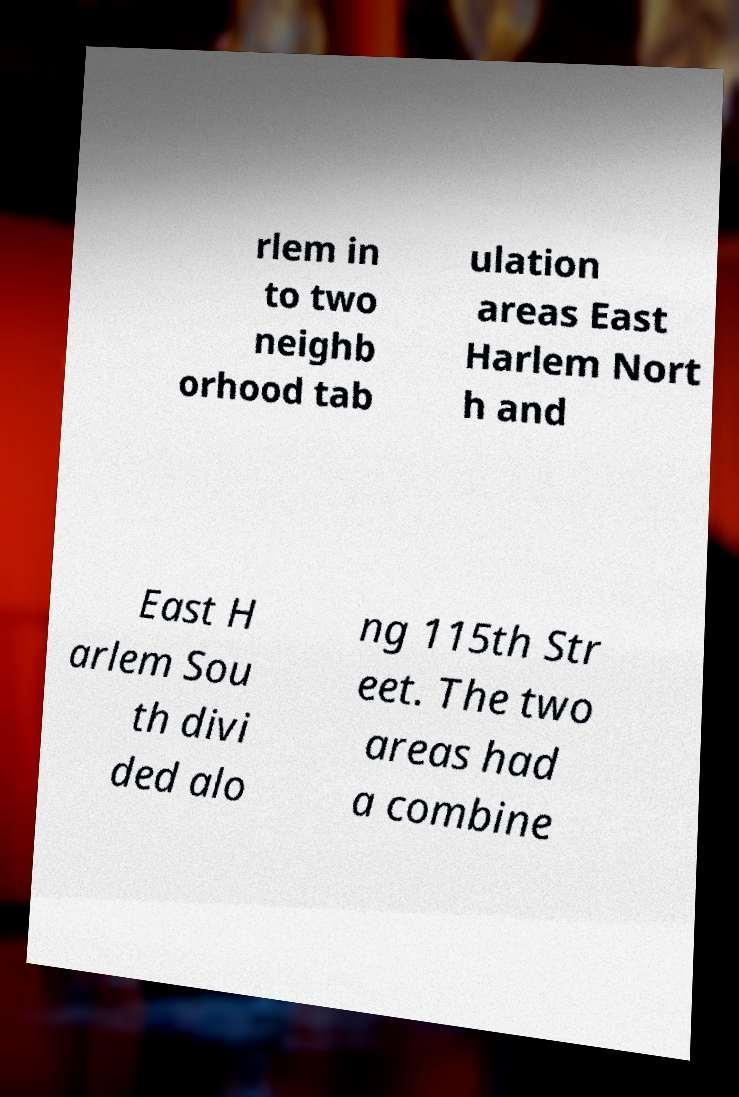Can you accurately transcribe the text from the provided image for me? rlem in to two neighb orhood tab ulation areas East Harlem Nort h and East H arlem Sou th divi ded alo ng 115th Str eet. The two areas had a combine 